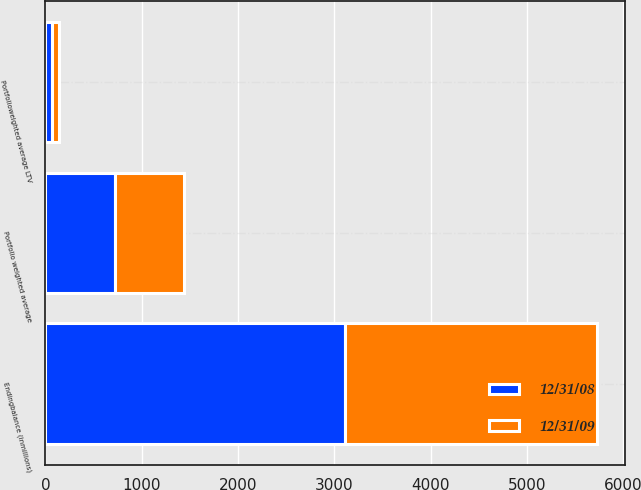<chart> <loc_0><loc_0><loc_500><loc_500><stacked_bar_chart><ecel><fcel>Endingbalance (inmillions)<fcel>Portfolioweighted average LTV<fcel>Portfolio weighted average<nl><fcel>12/31/09<fcel>2616<fcel>71<fcel>716<nl><fcel>12/31/08<fcel>3116<fcel>70<fcel>725<nl></chart> 